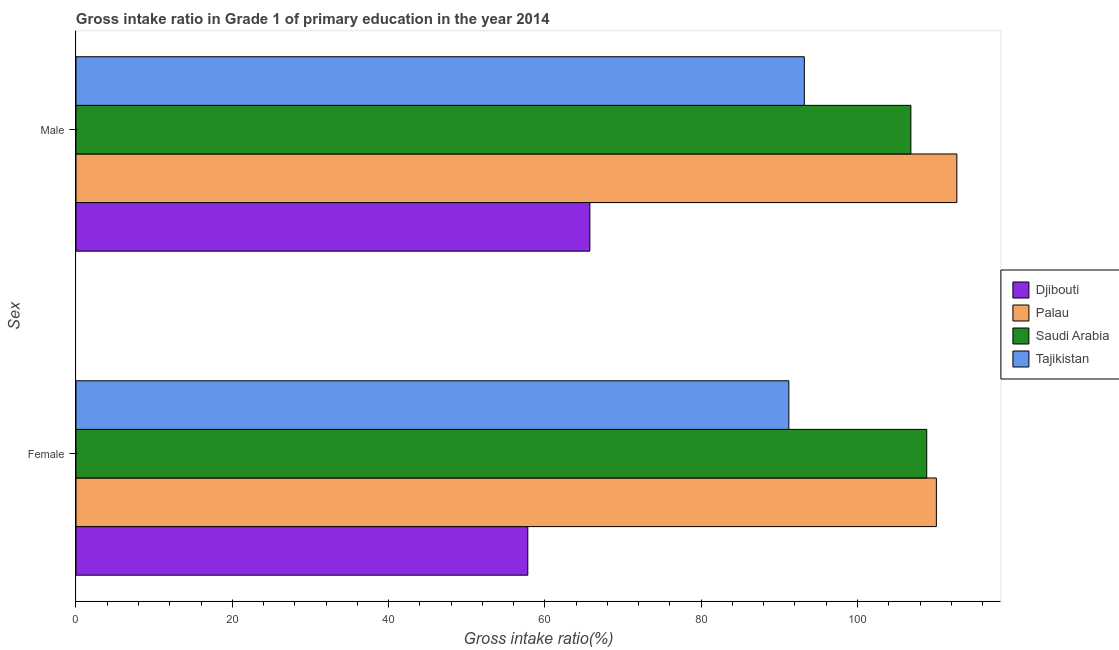How many different coloured bars are there?
Ensure brevity in your answer.  4. How many bars are there on the 2nd tick from the top?
Keep it short and to the point. 4. What is the gross intake ratio(female) in Tajikistan?
Your response must be concise. 91.22. Across all countries, what is the maximum gross intake ratio(female)?
Your answer should be very brief. 110.09. Across all countries, what is the minimum gross intake ratio(female)?
Your response must be concise. 57.81. In which country was the gross intake ratio(female) maximum?
Offer a very short reply. Palau. In which country was the gross intake ratio(male) minimum?
Your answer should be compact. Djibouti. What is the total gross intake ratio(male) in the graph?
Make the answer very short. 378.49. What is the difference between the gross intake ratio(female) in Tajikistan and that in Saudi Arabia?
Provide a succinct answer. -17.64. What is the difference between the gross intake ratio(female) in Tajikistan and the gross intake ratio(male) in Saudi Arabia?
Make the answer very short. -15.61. What is the average gross intake ratio(male) per country?
Make the answer very short. 94.62. What is the difference between the gross intake ratio(female) and gross intake ratio(male) in Saudi Arabia?
Offer a very short reply. 2.03. In how many countries, is the gross intake ratio(female) greater than 16 %?
Your answer should be very brief. 4. What is the ratio of the gross intake ratio(male) in Palau to that in Djibouti?
Provide a succinct answer. 1.71. What does the 2nd bar from the top in Female represents?
Offer a terse response. Saudi Arabia. What does the 2nd bar from the bottom in Female represents?
Ensure brevity in your answer.  Palau. How many bars are there?
Your response must be concise. 8. Does the graph contain any zero values?
Your response must be concise. No. Does the graph contain grids?
Your response must be concise. No. How many legend labels are there?
Keep it short and to the point. 4. How are the legend labels stacked?
Offer a very short reply. Vertical. What is the title of the graph?
Ensure brevity in your answer.  Gross intake ratio in Grade 1 of primary education in the year 2014. Does "Andorra" appear as one of the legend labels in the graph?
Keep it short and to the point. No. What is the label or title of the X-axis?
Make the answer very short. Gross intake ratio(%). What is the label or title of the Y-axis?
Ensure brevity in your answer.  Sex. What is the Gross intake ratio(%) in Djibouti in Female?
Your answer should be compact. 57.81. What is the Gross intake ratio(%) of Palau in Female?
Provide a succinct answer. 110.09. What is the Gross intake ratio(%) of Saudi Arabia in Female?
Your response must be concise. 108.86. What is the Gross intake ratio(%) in Tajikistan in Female?
Your response must be concise. 91.22. What is the Gross intake ratio(%) in Djibouti in Male?
Provide a short and direct response. 65.75. What is the Gross intake ratio(%) of Palau in Male?
Your answer should be very brief. 112.71. What is the Gross intake ratio(%) of Saudi Arabia in Male?
Make the answer very short. 106.83. What is the Gross intake ratio(%) of Tajikistan in Male?
Your answer should be compact. 93.19. Across all Sex, what is the maximum Gross intake ratio(%) of Djibouti?
Ensure brevity in your answer.  65.75. Across all Sex, what is the maximum Gross intake ratio(%) in Palau?
Ensure brevity in your answer.  112.71. Across all Sex, what is the maximum Gross intake ratio(%) of Saudi Arabia?
Offer a very short reply. 108.86. Across all Sex, what is the maximum Gross intake ratio(%) of Tajikistan?
Make the answer very short. 93.19. Across all Sex, what is the minimum Gross intake ratio(%) in Djibouti?
Your response must be concise. 57.81. Across all Sex, what is the minimum Gross intake ratio(%) of Palau?
Keep it short and to the point. 110.09. Across all Sex, what is the minimum Gross intake ratio(%) of Saudi Arabia?
Provide a succinct answer. 106.83. Across all Sex, what is the minimum Gross intake ratio(%) in Tajikistan?
Your answer should be very brief. 91.22. What is the total Gross intake ratio(%) in Djibouti in the graph?
Provide a short and direct response. 123.56. What is the total Gross intake ratio(%) in Palau in the graph?
Give a very brief answer. 222.8. What is the total Gross intake ratio(%) of Saudi Arabia in the graph?
Your answer should be very brief. 215.69. What is the total Gross intake ratio(%) of Tajikistan in the graph?
Your response must be concise. 184.41. What is the difference between the Gross intake ratio(%) of Djibouti in Female and that in Male?
Provide a succinct answer. -7.94. What is the difference between the Gross intake ratio(%) in Palau in Female and that in Male?
Provide a succinct answer. -2.62. What is the difference between the Gross intake ratio(%) in Saudi Arabia in Female and that in Male?
Provide a succinct answer. 2.03. What is the difference between the Gross intake ratio(%) in Tajikistan in Female and that in Male?
Offer a very short reply. -1.98. What is the difference between the Gross intake ratio(%) of Djibouti in Female and the Gross intake ratio(%) of Palau in Male?
Give a very brief answer. -54.9. What is the difference between the Gross intake ratio(%) in Djibouti in Female and the Gross intake ratio(%) in Saudi Arabia in Male?
Provide a short and direct response. -49.02. What is the difference between the Gross intake ratio(%) of Djibouti in Female and the Gross intake ratio(%) of Tajikistan in Male?
Make the answer very short. -35.38. What is the difference between the Gross intake ratio(%) of Palau in Female and the Gross intake ratio(%) of Saudi Arabia in Male?
Give a very brief answer. 3.26. What is the difference between the Gross intake ratio(%) in Palau in Female and the Gross intake ratio(%) in Tajikistan in Male?
Your response must be concise. 16.9. What is the difference between the Gross intake ratio(%) in Saudi Arabia in Female and the Gross intake ratio(%) in Tajikistan in Male?
Provide a succinct answer. 15.66. What is the average Gross intake ratio(%) in Djibouti per Sex?
Offer a very short reply. 61.78. What is the average Gross intake ratio(%) of Palau per Sex?
Ensure brevity in your answer.  111.4. What is the average Gross intake ratio(%) of Saudi Arabia per Sex?
Offer a very short reply. 107.84. What is the average Gross intake ratio(%) of Tajikistan per Sex?
Offer a terse response. 92.21. What is the difference between the Gross intake ratio(%) of Djibouti and Gross intake ratio(%) of Palau in Female?
Keep it short and to the point. -52.28. What is the difference between the Gross intake ratio(%) in Djibouti and Gross intake ratio(%) in Saudi Arabia in Female?
Provide a short and direct response. -51.05. What is the difference between the Gross intake ratio(%) of Djibouti and Gross intake ratio(%) of Tajikistan in Female?
Offer a very short reply. -33.41. What is the difference between the Gross intake ratio(%) in Palau and Gross intake ratio(%) in Saudi Arabia in Female?
Make the answer very short. 1.23. What is the difference between the Gross intake ratio(%) in Palau and Gross intake ratio(%) in Tajikistan in Female?
Keep it short and to the point. 18.88. What is the difference between the Gross intake ratio(%) of Saudi Arabia and Gross intake ratio(%) of Tajikistan in Female?
Provide a short and direct response. 17.64. What is the difference between the Gross intake ratio(%) in Djibouti and Gross intake ratio(%) in Palau in Male?
Make the answer very short. -46.96. What is the difference between the Gross intake ratio(%) of Djibouti and Gross intake ratio(%) of Saudi Arabia in Male?
Offer a terse response. -41.08. What is the difference between the Gross intake ratio(%) of Djibouti and Gross intake ratio(%) of Tajikistan in Male?
Provide a short and direct response. -27.44. What is the difference between the Gross intake ratio(%) in Palau and Gross intake ratio(%) in Saudi Arabia in Male?
Provide a succinct answer. 5.88. What is the difference between the Gross intake ratio(%) in Palau and Gross intake ratio(%) in Tajikistan in Male?
Make the answer very short. 19.52. What is the difference between the Gross intake ratio(%) in Saudi Arabia and Gross intake ratio(%) in Tajikistan in Male?
Your answer should be very brief. 13.63. What is the ratio of the Gross intake ratio(%) in Djibouti in Female to that in Male?
Provide a short and direct response. 0.88. What is the ratio of the Gross intake ratio(%) of Palau in Female to that in Male?
Keep it short and to the point. 0.98. What is the ratio of the Gross intake ratio(%) of Tajikistan in Female to that in Male?
Ensure brevity in your answer.  0.98. What is the difference between the highest and the second highest Gross intake ratio(%) of Djibouti?
Your answer should be very brief. 7.94. What is the difference between the highest and the second highest Gross intake ratio(%) of Palau?
Your answer should be very brief. 2.62. What is the difference between the highest and the second highest Gross intake ratio(%) in Saudi Arabia?
Your answer should be compact. 2.03. What is the difference between the highest and the second highest Gross intake ratio(%) of Tajikistan?
Your response must be concise. 1.98. What is the difference between the highest and the lowest Gross intake ratio(%) of Djibouti?
Make the answer very short. 7.94. What is the difference between the highest and the lowest Gross intake ratio(%) of Palau?
Provide a succinct answer. 2.62. What is the difference between the highest and the lowest Gross intake ratio(%) of Saudi Arabia?
Ensure brevity in your answer.  2.03. What is the difference between the highest and the lowest Gross intake ratio(%) of Tajikistan?
Ensure brevity in your answer.  1.98. 